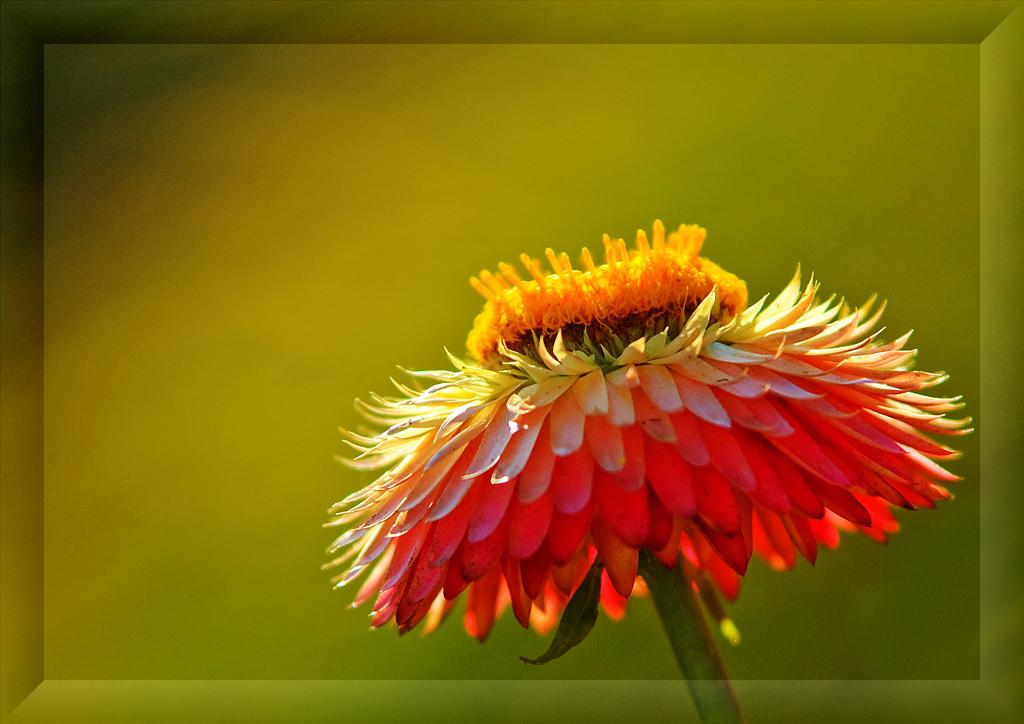What is the main subject of the image? There is a flower in the image. Can you describe the background of the image? The background of the image is blurry. What type of advice can be seen written on the sofa in the image? There is no sofa or advice present in the image; it features a flower with a blurry background. 